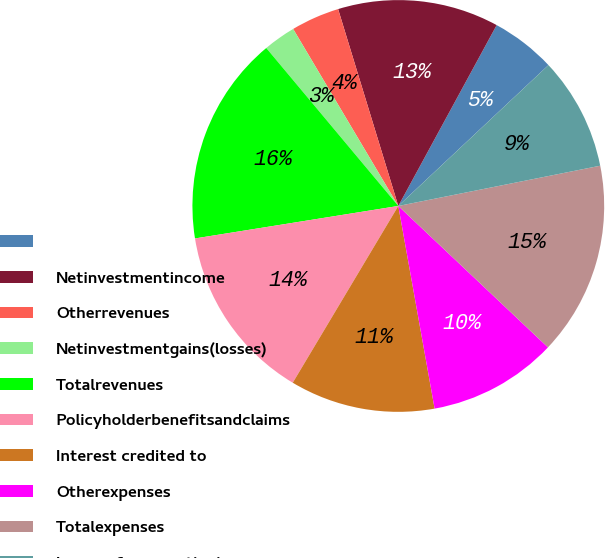Convert chart. <chart><loc_0><loc_0><loc_500><loc_500><pie_chart><ecel><fcel>Netinvestmentincome<fcel>Otherrevenues<fcel>Netinvestmentgains(losses)<fcel>Totalrevenues<fcel>Policyholderbenefitsandclaims<fcel>Interest credited to<fcel>Otherexpenses<fcel>Totalexpenses<fcel>Income from continuing<nl><fcel>5.08%<fcel>12.65%<fcel>3.81%<fcel>2.55%<fcel>16.44%<fcel>13.91%<fcel>11.39%<fcel>10.13%<fcel>15.18%<fcel>8.86%<nl></chart> 